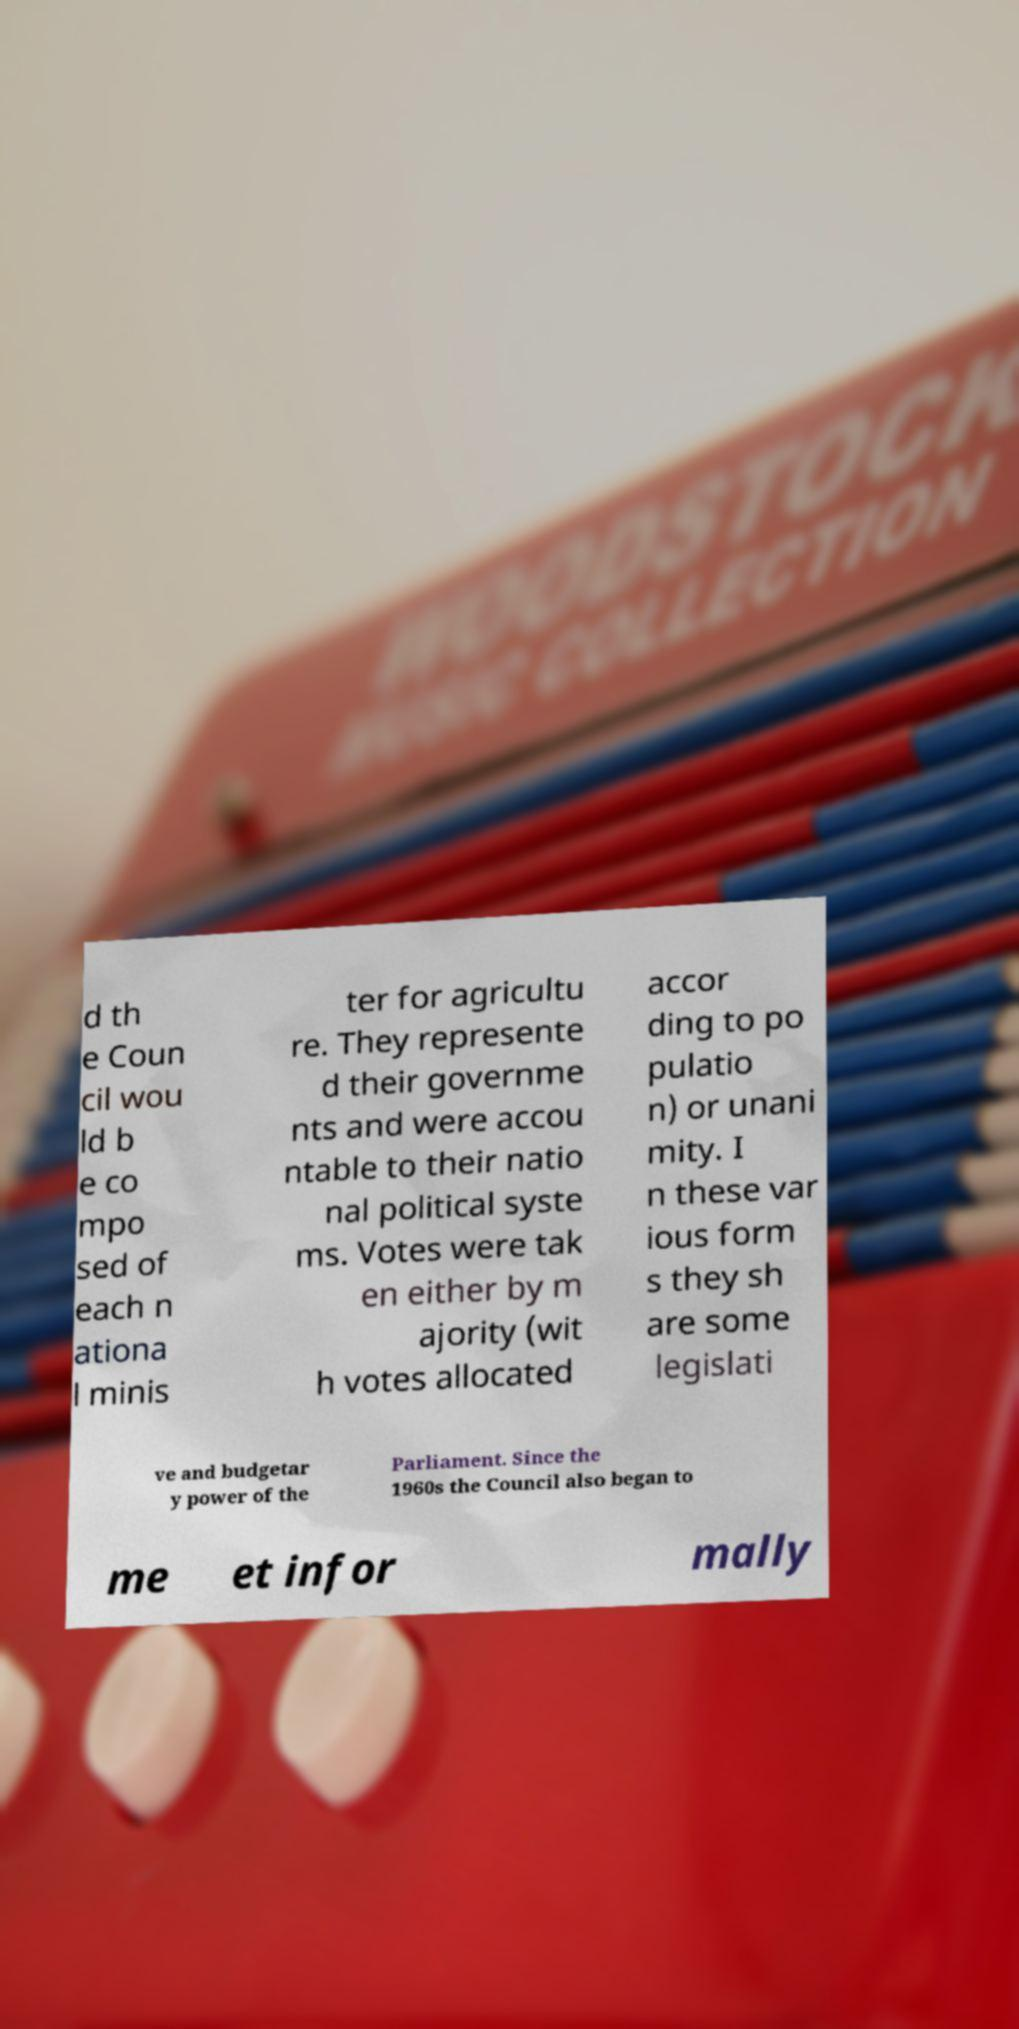I need the written content from this picture converted into text. Can you do that? d th e Coun cil wou ld b e co mpo sed of each n ationa l minis ter for agricultu re. They represente d their governme nts and were accou ntable to their natio nal political syste ms. Votes were tak en either by m ajority (wit h votes allocated accor ding to po pulatio n) or unani mity. I n these var ious form s they sh are some legislati ve and budgetar y power of the Parliament. Since the 1960s the Council also began to me et infor mally 